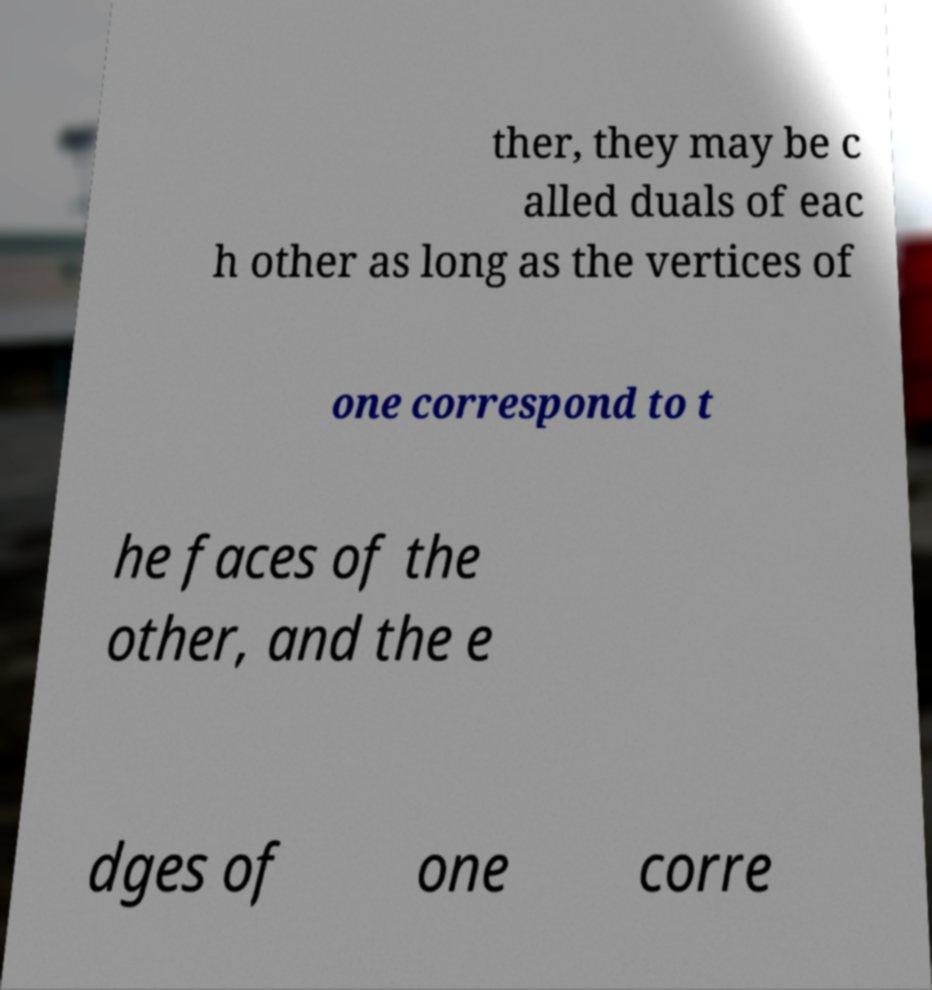What messages or text are displayed in this image? I need them in a readable, typed format. ther, they may be c alled duals of eac h other as long as the vertices of one correspond to t he faces of the other, and the e dges of one corre 